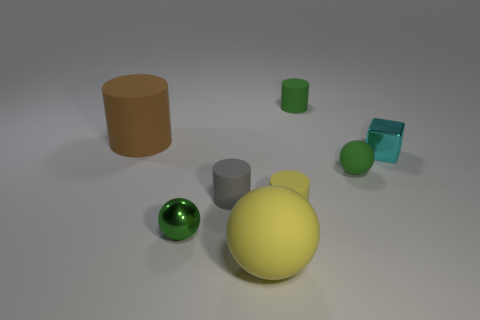Is there any other thing that has the same size as the block? Based on the image, while absolute measurements cannot be confirmed without a scale or reference, it appears that the green sphere is the closest in size to the light blue cube-like block. However, given the perspective, this is an estimation and actual dimensions may vary. 